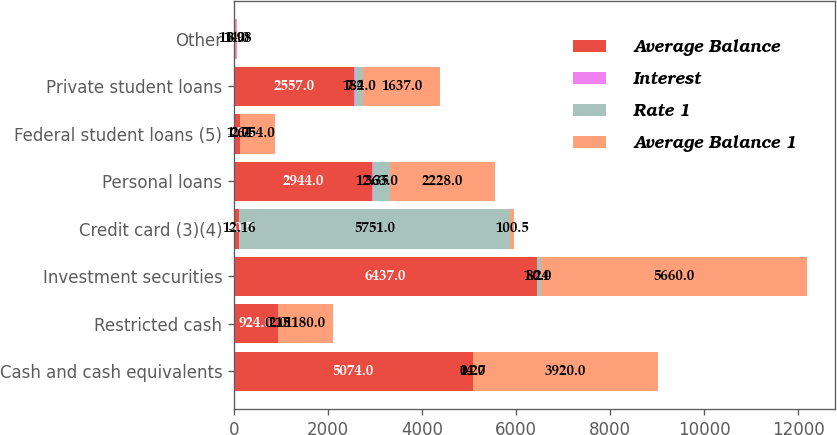<chart> <loc_0><loc_0><loc_500><loc_500><stacked_bar_chart><ecel><fcel>Cash and cash equivalents<fcel>Restricted cash<fcel>Investment securities<fcel>Credit card (3)(4)<fcel>Personal loans<fcel>Federal student loans (5)<fcel>Private student loans<fcel>Other<nl><fcel>Average Balance<fcel>5074<fcel>924<fcel>6437<fcel>100.5<fcel>2944<fcel>121<fcel>2557<fcel>26<nl><fcel>Interest<fcel>0.27<fcel>0.15<fcel>1.24<fcel>12.16<fcel>12.35<fcel>1.64<fcel>7.2<fcel>11.98<nl><fcel>Rate 1<fcel>14<fcel>2<fcel>80<fcel>5751<fcel>363<fcel>2<fcel>184<fcel>3<nl><fcel>Average Balance 1<fcel>3920<fcel>1180<fcel>5660<fcel>100.5<fcel>2228<fcel>754<fcel>1637<fcel>14<nl></chart> 